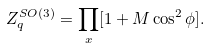<formula> <loc_0><loc_0><loc_500><loc_500>Z _ { q } ^ { S O ( 3 ) } = \prod _ { x } [ 1 + M \cos ^ { 2 } \phi ] .</formula> 